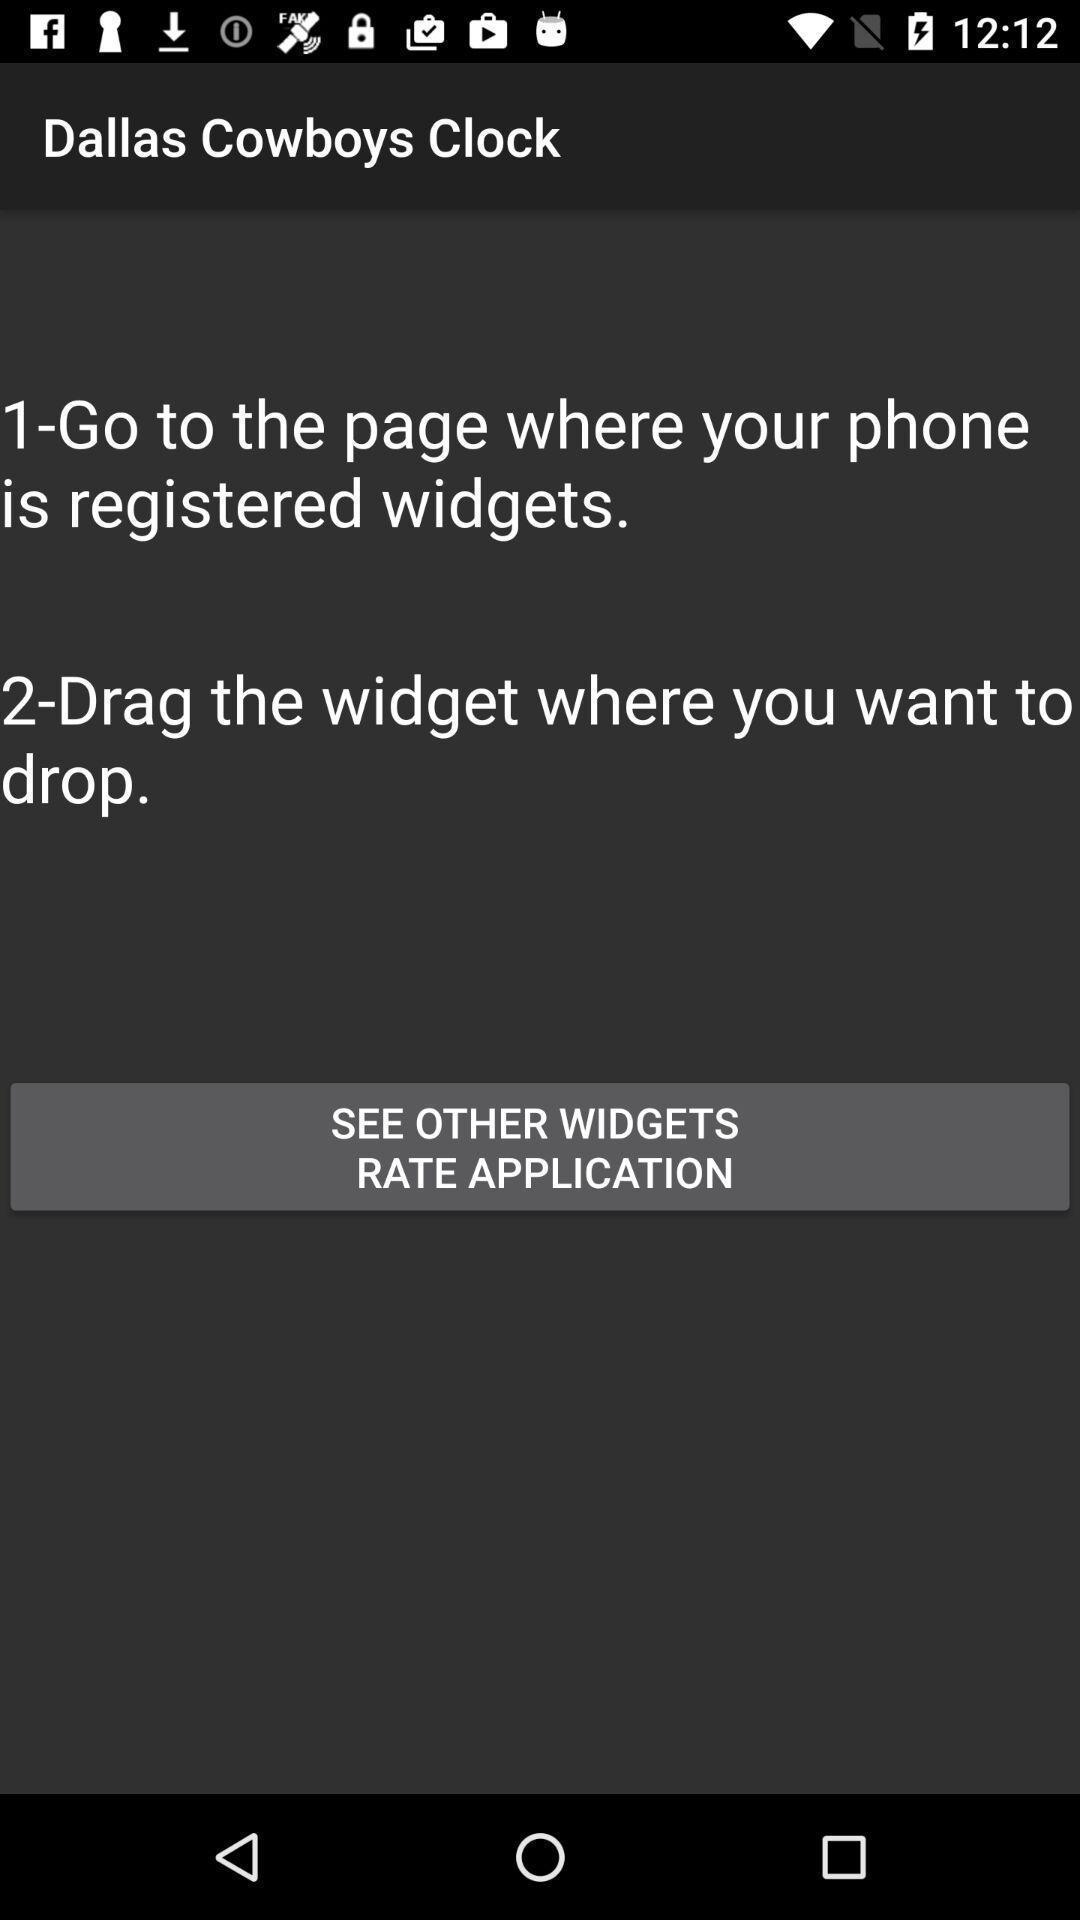Explain what's happening in this screen capture. Text in the mobile regarding widget application. 